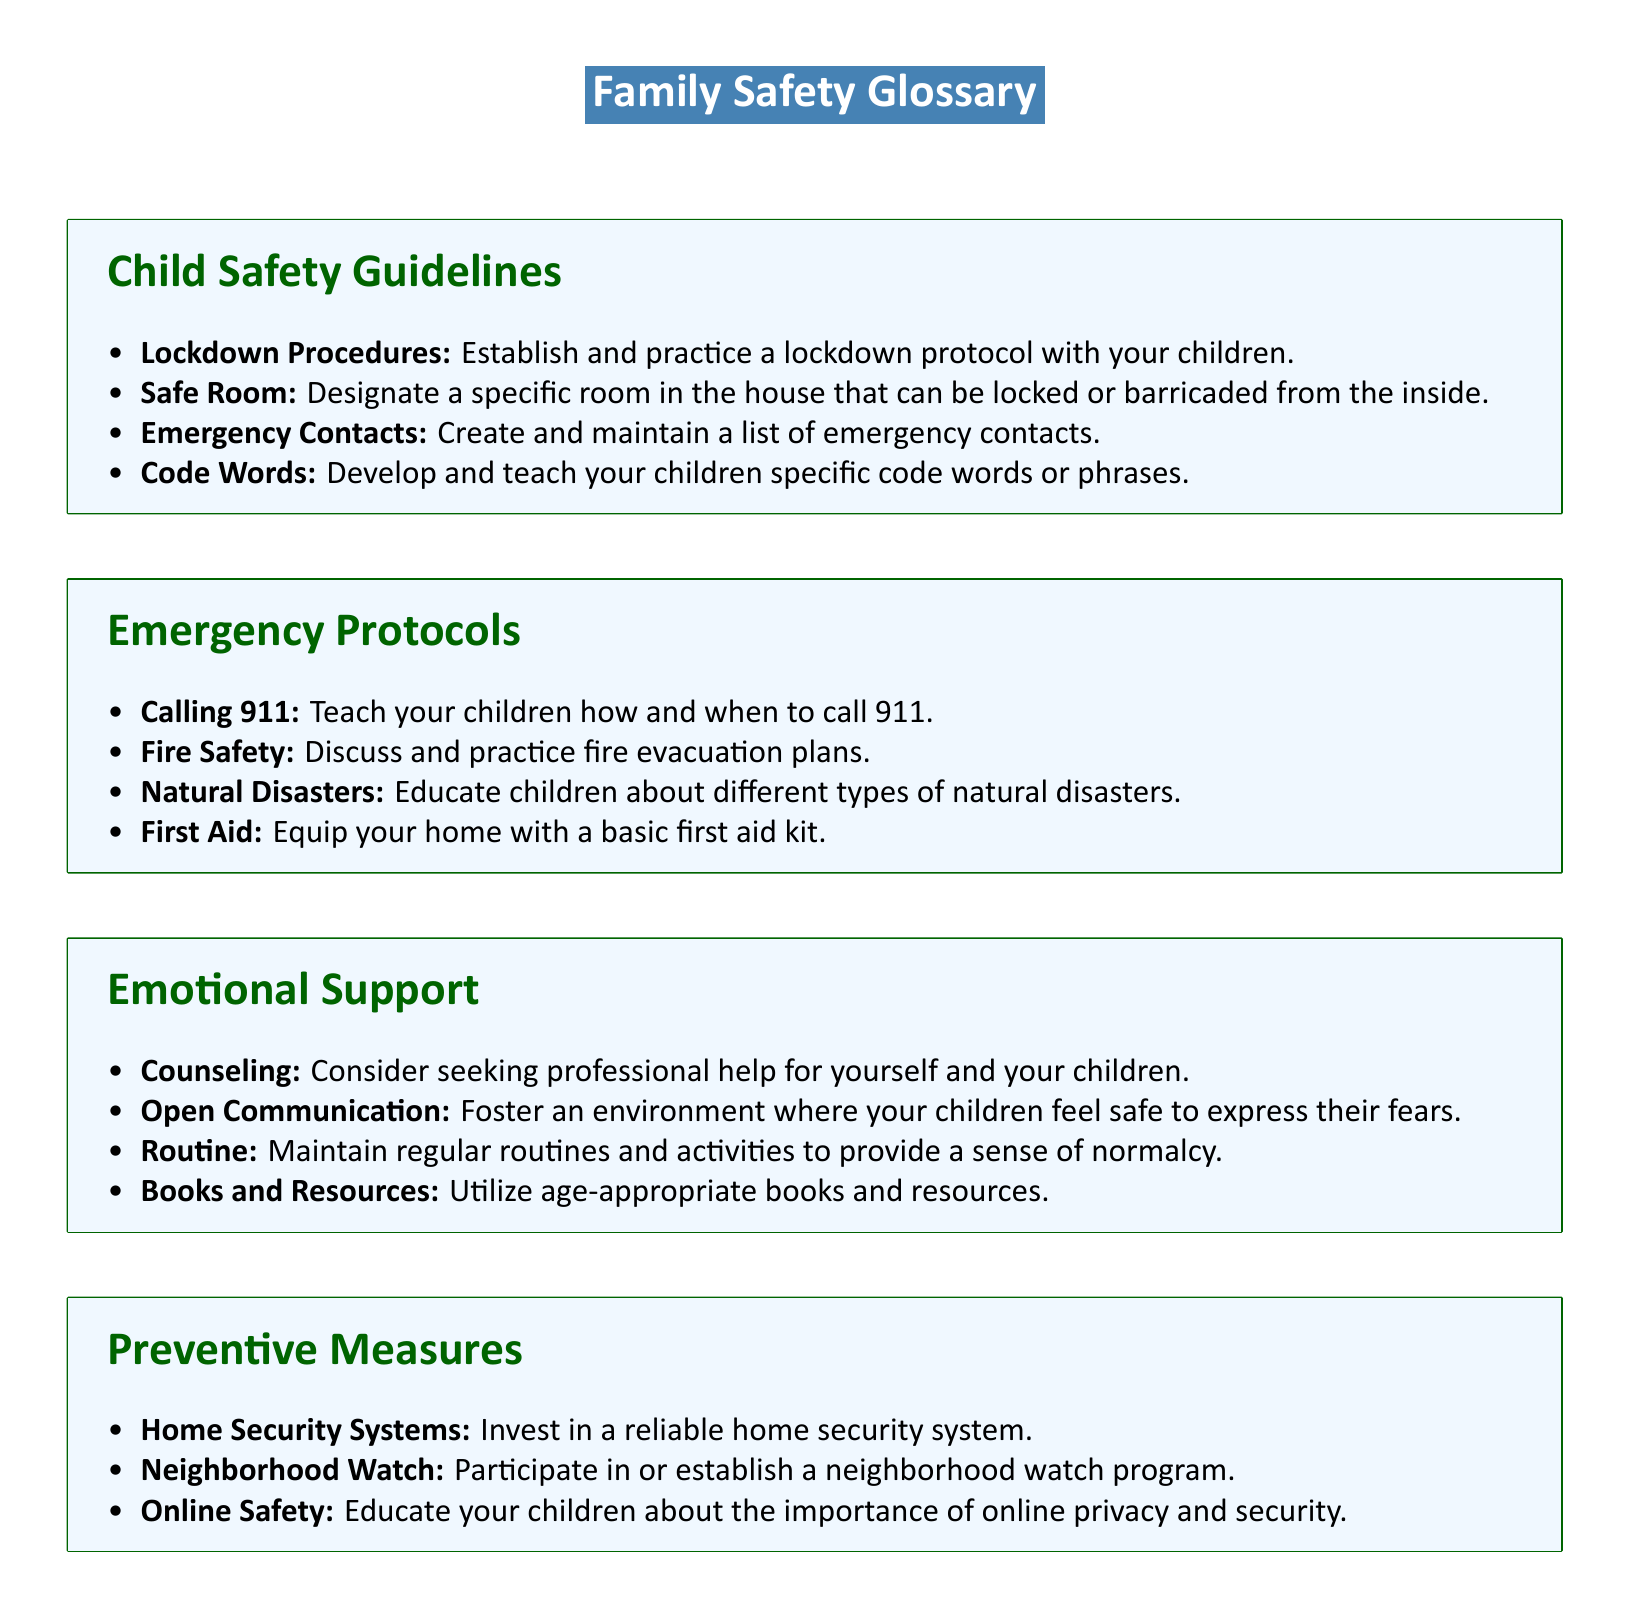what is the title of the document? The title of the document is indicated in a color box at the top, which clearly states "Family Safety Glossary."
Answer: Family Safety Glossary how many sections are in the document? The document contains four main sections: Child Safety Guidelines, Emergency Protocols, Emotional Support, and Preventive Measures.
Answer: Four what is one example of a lockdown procedure? The document lists "Establish and practice a lockdown protocol with your children" as part of child safety guidelines.
Answer: Lockdown protocol what should be included in the emergency contacts list? The emergency contacts list should comprise people whom the family can reach out to in case of emergencies, as mentioned in the section on Child Safety Guidelines.
Answer: Emergency contacts what is an example of a preventive measure? The document lists "Invest in a reliable home security system" under Preventive Measures.
Answer: Home security system how many items are listed under Emotional Support? The document lists four items under Emotional Support including Counseling, Open Communication, Routine, and Books and Resources.
Answer: Four what is the purpose of the code words mentioned? The code words are developed and taught to children to ensure they can communicate safety-related messages effectively.
Answer: Communication what practice should be discussed with children for fire safety? The protocol for fire safety includes discussing and practicing fire evacuation plans.
Answer: Fire evacuation plans what should you do if you need professional help? The document suggests considering "Counseling" as an option for emotional support.
Answer: Counseling 